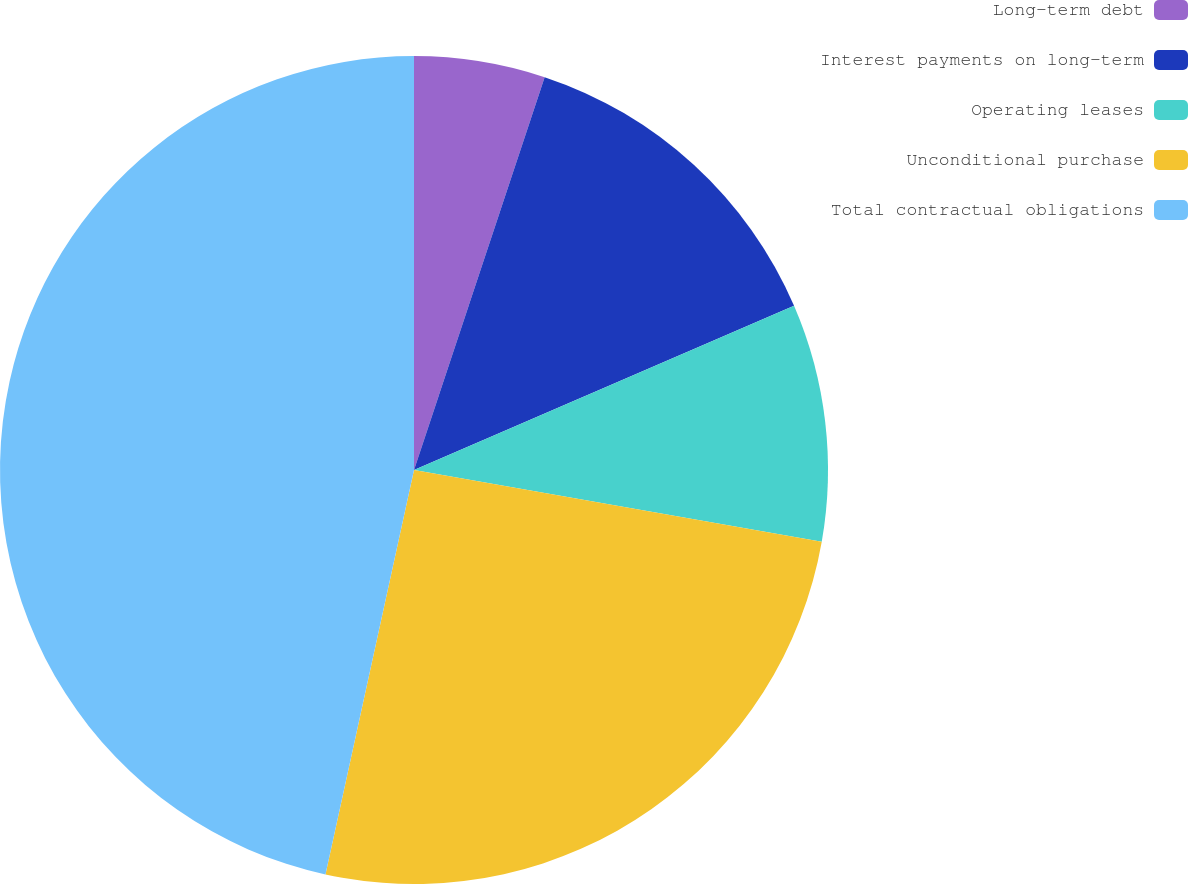Convert chart. <chart><loc_0><loc_0><loc_500><loc_500><pie_chart><fcel>Long-term debt<fcel>Interest payments on long-term<fcel>Operating leases<fcel>Unconditional purchase<fcel>Total contractual obligations<nl><fcel>5.11%<fcel>13.4%<fcel>9.26%<fcel>25.66%<fcel>46.57%<nl></chart> 